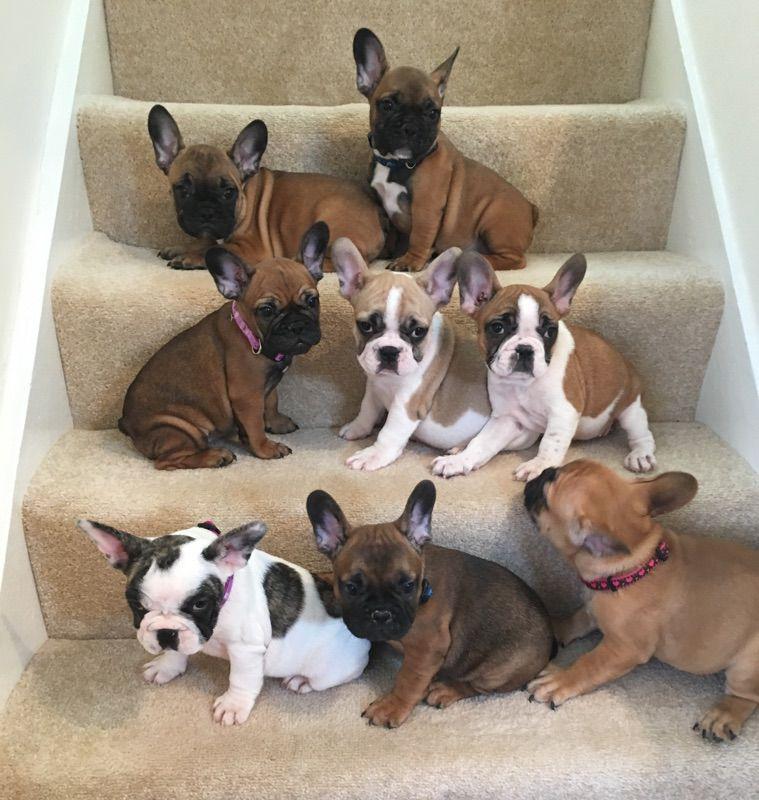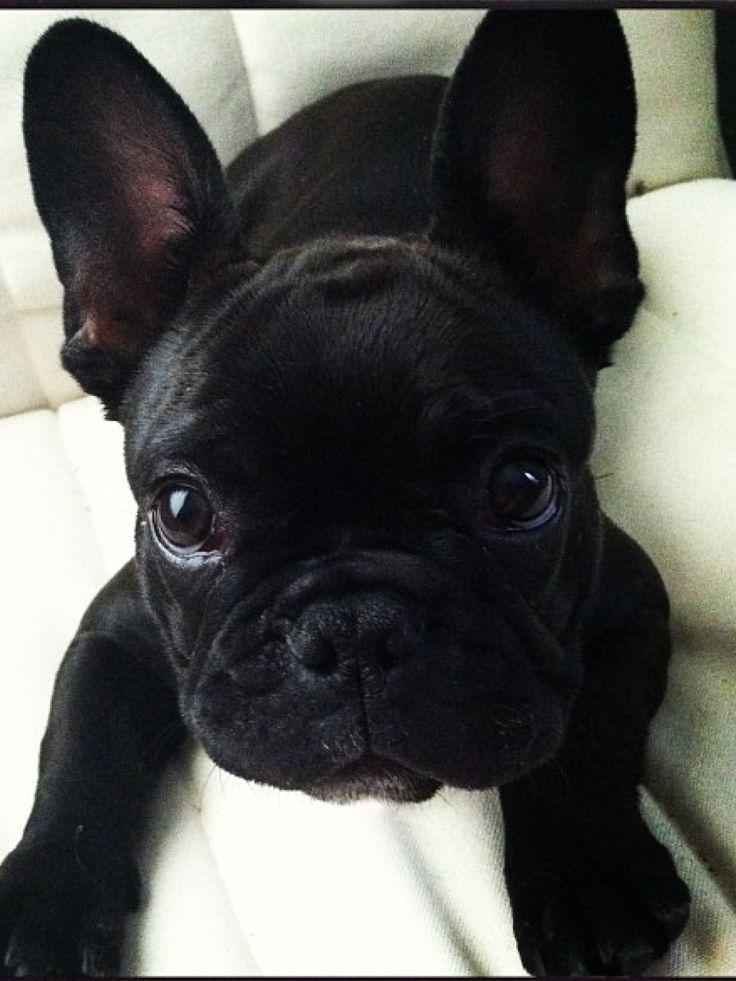The first image is the image on the left, the second image is the image on the right. Examine the images to the left and right. Is the description "A single black dog is opposite at least three dogs of multiple colors." accurate? Answer yes or no. Yes. The first image is the image on the left, the second image is the image on the right. Analyze the images presented: Is the assertion "There are  3 dogs sitting with white fur on their chest." valid? Answer yes or no. No. 